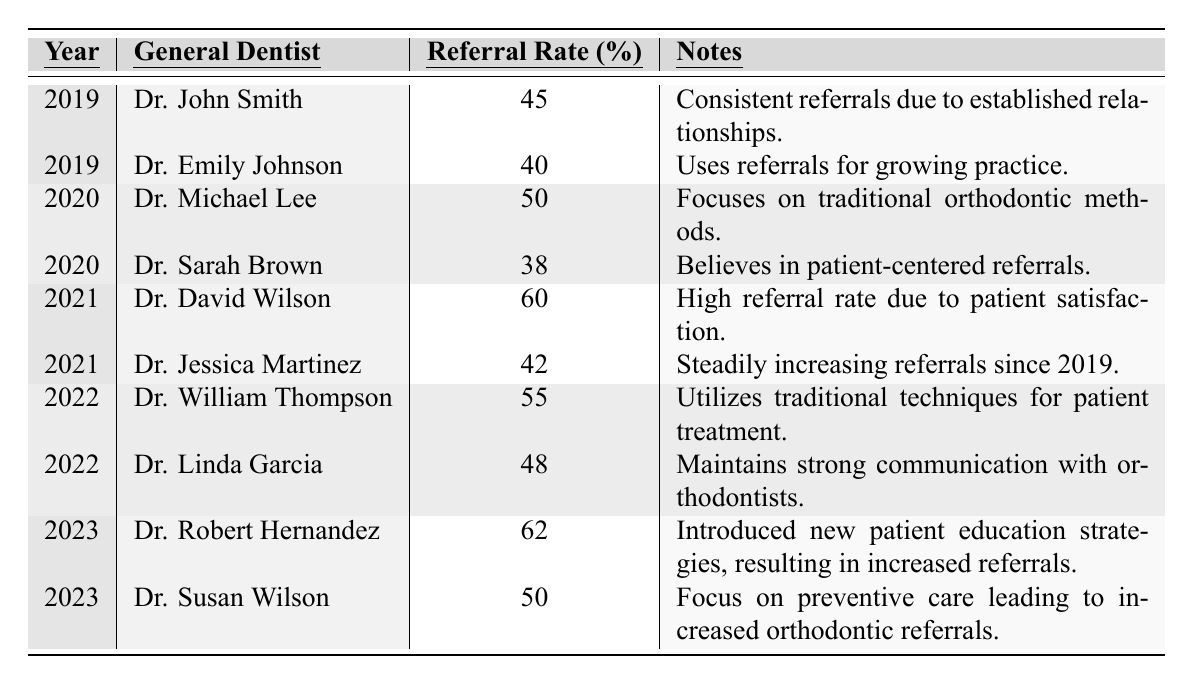What was the highest referral rate reported in 2022? The table shows Dr. William Thompson with a referral rate of 55% in 2022, which is the highest listed for that year.
Answer: 55% Which dentist had the lowest referral rate in 2019? Dr. Emily Johnson had the lowest referral rate of 40% among the two dentists listed for 2019.
Answer: 40% What is the average referral rate for the year 2020? To find the average, sum the referral rates for the two dentists in 2020 (50 + 38 = 88) and divide by the number of dentists (2). The average is 88 / 2 = 44%.
Answer: 44% Is there an increase in referral rates from 2021 to 2023 for Dr. Robert Hernandez? Yes, Dr. Robert Hernandez's referral rate increased from 62% in 2023. Comparing previous years' data shows a consistent increase leading up to this year.
Answer: Yes What is the percentage increase in referral rate from Dr. Michael Lee in 2020 to Dr. David Wilson in 2021? Dr. Michael Lee had a referral rate of 50% in 2020, while Dr. David Wilson had a rate of 60% in 2021. The increase is calculated as (60 - 50) / 50 * 100 = 20%.
Answer: 20% Which general dentist had the highest referral rate in the entire table? Dr. Robert Hernandez in 2023 had the highest referral rate at 62%, which is more than any other dentist in the table from 2019 to 2023.
Answer: 62% Did Dr. Sarah Brown's referral rate improve from 2020 to 2021? No, Dr. Sarah Brown's referral rate was 38% in 2020 and did not change as she is not listed again in 2021.
Answer: No What trend can be observed for Dr. Jessica Martinez's referral rate from 2019 to 2021? Dr. Jessica Martinez's referral rate started at 42% in 2021 and increased steadily compared to previous years, indicating a positive trend without a recorded value for 2019.
Answer: Increasing trend What was the total number of referrals recorded in 2022? The total referral rates for 2022 are from two dentists: 55% from Dr. William Thompson and 48% from Dr. Linda Garcia, adding these gives 55 + 48 = 103%.
Answer: 103% Which year had the highest average referral rate? First, calculate the average for each year: 2019 (42.5%), 2020 (44%), 2021 (51%), 2022 (51.5%), and 2023 (56%). The highest average is in 2023 with a calculated average of 56%.
Answer: 2023 